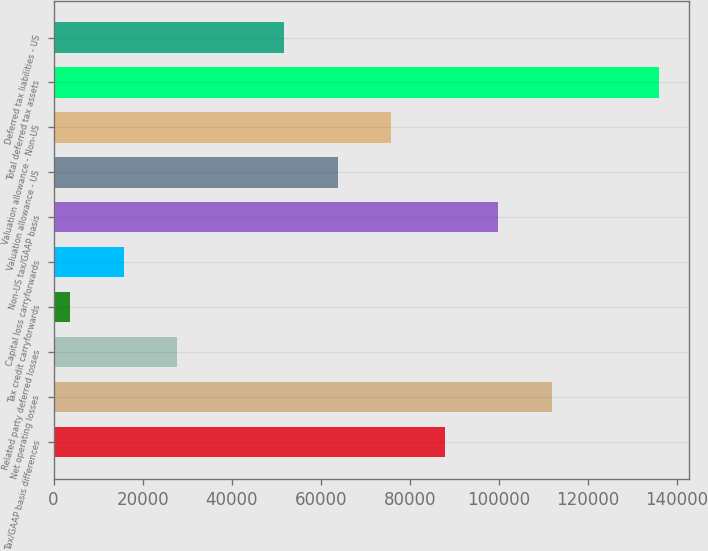<chart> <loc_0><loc_0><loc_500><loc_500><bar_chart><fcel>Tax/GAAP basis differences<fcel>Net operating losses<fcel>Related party deferred losses<fcel>Tax credit carryforwards<fcel>Capital loss carryforwards<fcel>Non-US tax/GAAP basis<fcel>Valuation allowance - US<fcel>Valuation allowance - Non-US<fcel>Total deferred tax assets<fcel>Deferred tax liabilities - US<nl><fcel>87869.6<fcel>111897<fcel>27800.6<fcel>3773<fcel>15786.8<fcel>99883.4<fcel>63842<fcel>75855.8<fcel>135925<fcel>51828.2<nl></chart> 